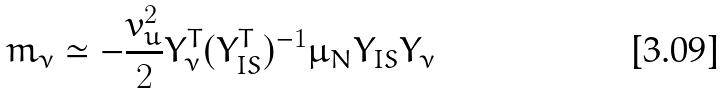Convert formula to latex. <formula><loc_0><loc_0><loc_500><loc_500>m _ { \nu } \simeq - \frac { v _ { u } ^ { 2 } } { 2 } Y ^ { T } _ { \nu } ( Y ^ { T } _ { I S } ) ^ { - 1 } \mu _ { N } Y _ { I S } Y _ { \nu }</formula> 